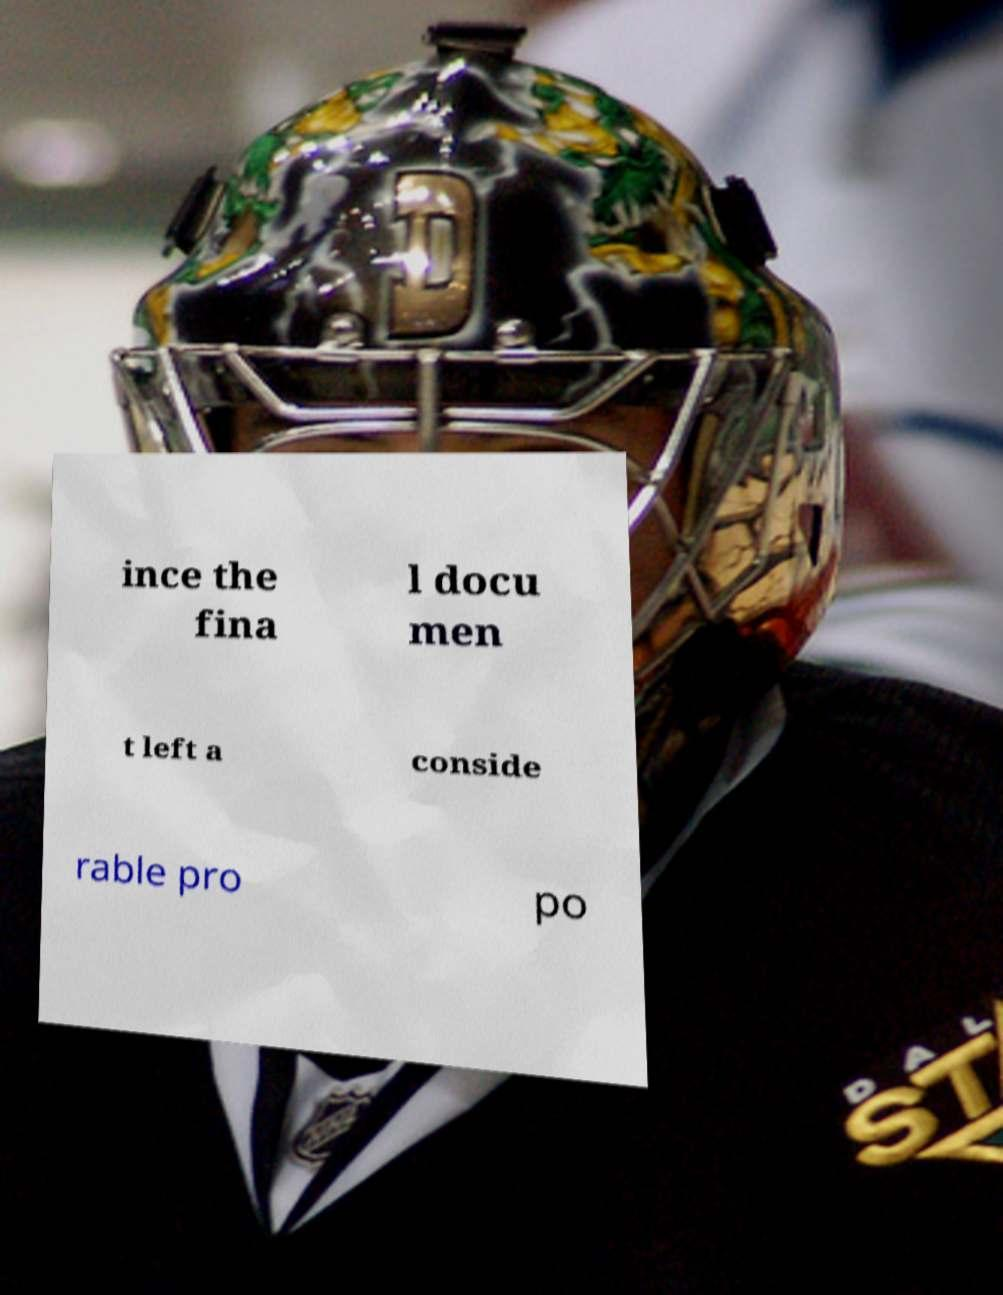Please identify and transcribe the text found in this image. ince the fina l docu men t left a conside rable pro po 